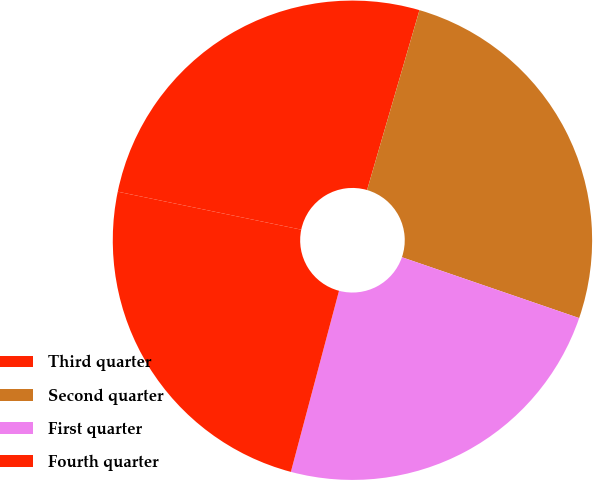Convert chart. <chart><loc_0><loc_0><loc_500><loc_500><pie_chart><fcel>Third quarter<fcel>Second quarter<fcel>First quarter<fcel>Fourth quarter<nl><fcel>26.26%<fcel>25.75%<fcel>23.87%<fcel>24.11%<nl></chart> 